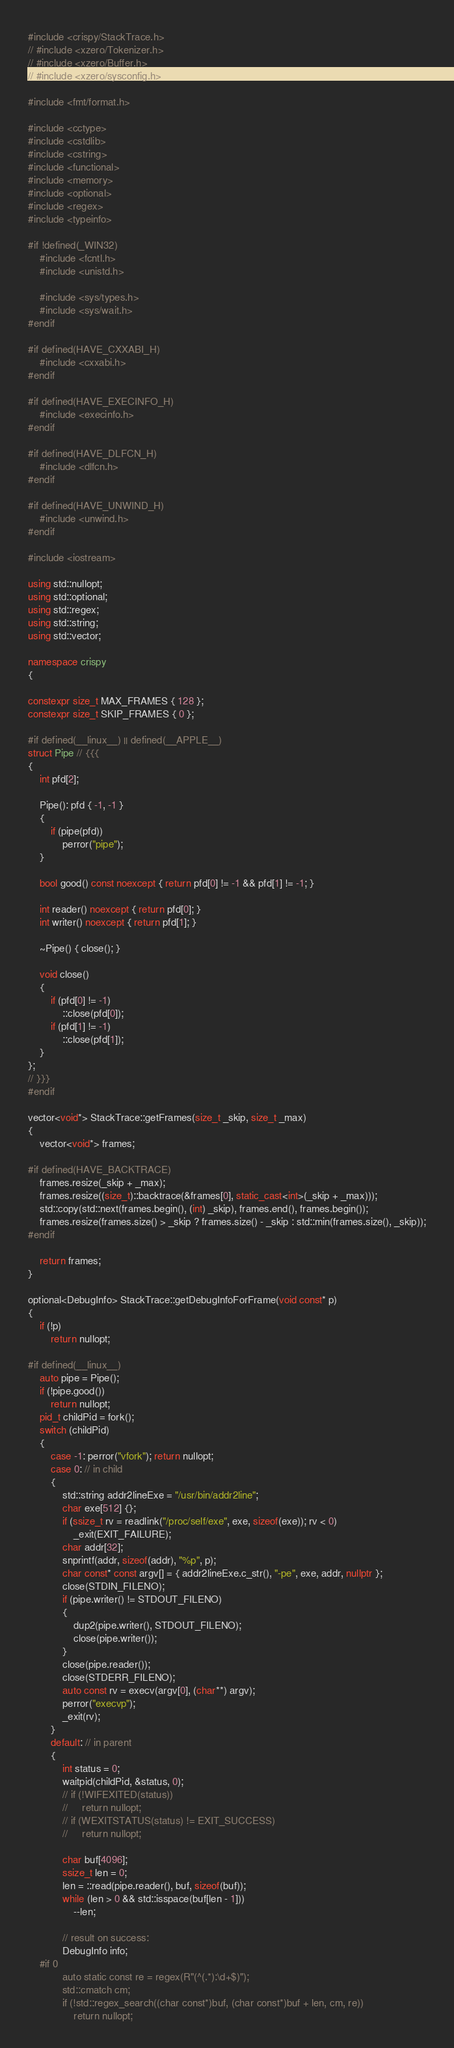Convert code to text. <code><loc_0><loc_0><loc_500><loc_500><_C++_>#include <crispy/StackTrace.h>
// #include <xzero/Tokenizer.h>
// #include <xzero/Buffer.h>
// #include <xzero/sysconfig.h>

#include <fmt/format.h>

#include <cctype>
#include <cstdlib>
#include <cstring>
#include <functional>
#include <memory>
#include <optional>
#include <regex>
#include <typeinfo>

#if !defined(_WIN32)
    #include <fcntl.h>
    #include <unistd.h>

    #include <sys/types.h>
    #include <sys/wait.h>
#endif

#if defined(HAVE_CXXABI_H)
    #include <cxxabi.h>
#endif

#if defined(HAVE_EXECINFO_H)
    #include <execinfo.h>
#endif

#if defined(HAVE_DLFCN_H)
    #include <dlfcn.h>
#endif

#if defined(HAVE_UNWIND_H)
    #include <unwind.h>
#endif

#include <iostream>

using std::nullopt;
using std::optional;
using std::regex;
using std::string;
using std::vector;

namespace crispy
{

constexpr size_t MAX_FRAMES { 128 };
constexpr size_t SKIP_FRAMES { 0 };

#if defined(__linux__) || defined(__APPLE__)
struct Pipe // {{{
{
    int pfd[2];

    Pipe(): pfd { -1, -1 }
    {
        if (pipe(pfd))
            perror("pipe");
    }

    bool good() const noexcept { return pfd[0] != -1 && pfd[1] != -1; }

    int reader() noexcept { return pfd[0]; }
    int writer() noexcept { return pfd[1]; }

    ~Pipe() { close(); }

    void close()
    {
        if (pfd[0] != -1)
            ::close(pfd[0]);
        if (pfd[1] != -1)
            ::close(pfd[1]);
    }
};
// }}}
#endif

vector<void*> StackTrace::getFrames(size_t _skip, size_t _max)
{
    vector<void*> frames;

#if defined(HAVE_BACKTRACE)
    frames.resize(_skip + _max);
    frames.resize((size_t)::backtrace(&frames[0], static_cast<int>(_skip + _max)));
    std::copy(std::next(frames.begin(), (int) _skip), frames.end(), frames.begin());
    frames.resize(frames.size() > _skip ? frames.size() - _skip : std::min(frames.size(), _skip));
#endif

    return frames;
}

optional<DebugInfo> StackTrace::getDebugInfoForFrame(void const* p)
{
    if (!p)
        return nullopt;

#if defined(__linux__)
    auto pipe = Pipe();
    if (!pipe.good())
        return nullopt;
    pid_t childPid = fork();
    switch (childPid)
    {
        case -1: perror("vfork"); return nullopt;
        case 0: // in child
        {
            std::string addr2lineExe = "/usr/bin/addr2line";
            char exe[512] {};
            if (ssize_t rv = readlink("/proc/self/exe", exe, sizeof(exe)); rv < 0)
                _exit(EXIT_FAILURE);
            char addr[32];
            snprintf(addr, sizeof(addr), "%p", p);
            char const* const argv[] = { addr2lineExe.c_str(), "-pe", exe, addr, nullptr };
            close(STDIN_FILENO);
            if (pipe.writer() != STDOUT_FILENO)
            {
                dup2(pipe.writer(), STDOUT_FILENO);
                close(pipe.writer());
            }
            close(pipe.reader());
            close(STDERR_FILENO);
            auto const rv = execv(argv[0], (char**) argv);
            perror("execvp");
            _exit(rv);
        }
        default: // in parent
        {
            int status = 0;
            waitpid(childPid, &status, 0);
            // if (!WIFEXITED(status))
            //     return nullopt;
            // if (WEXITSTATUS(status) != EXIT_SUCCESS)
            //     return nullopt;

            char buf[4096];
            ssize_t len = 0;
            len = ::read(pipe.reader(), buf, sizeof(buf));
            while (len > 0 && std::isspace(buf[len - 1]))
                --len;

            // result on success:
            DebugInfo info;
    #if 0
            auto static const re = regex(R"(^(.*):\d+$)");
            std::cmatch cm;
            if (!std::regex_search((char const*)buf, (char const*)buf + len, cm, re))
                return nullopt;
</code> 